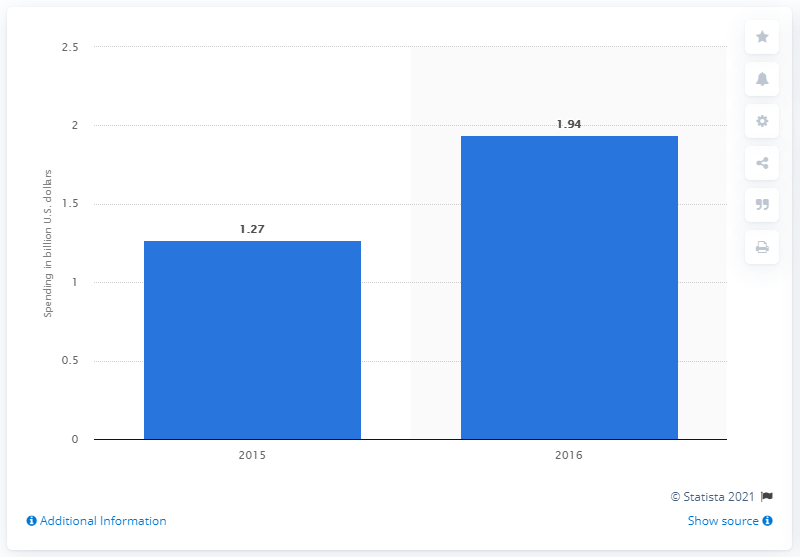Outline some significant characteristics in this image. In 2015, digital magazines in the U.S. spent 1.27 billion dollars. 